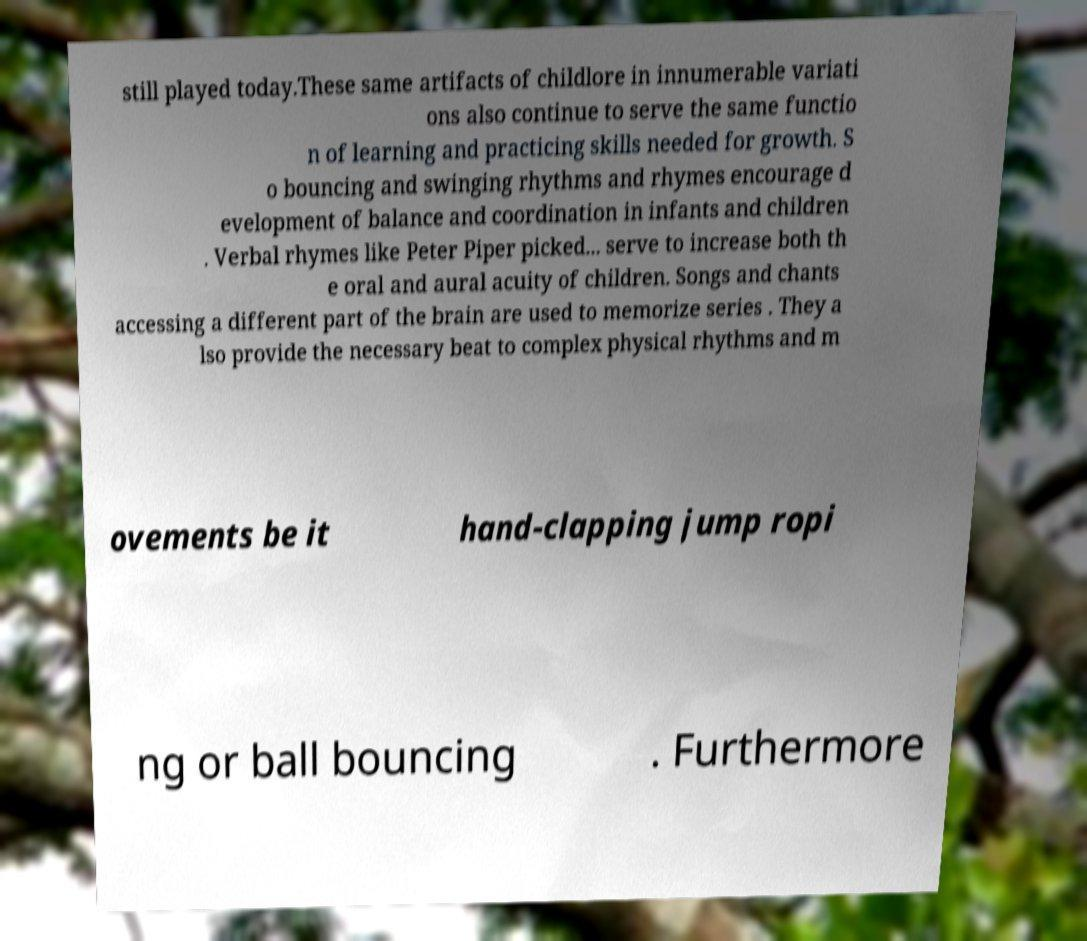I need the written content from this picture converted into text. Can you do that? still played today.These same artifacts of childlore in innumerable variati ons also continue to serve the same functio n of learning and practicing skills needed for growth. S o bouncing and swinging rhythms and rhymes encourage d evelopment of balance and coordination in infants and children . Verbal rhymes like Peter Piper picked... serve to increase both th e oral and aural acuity of children. Songs and chants accessing a different part of the brain are used to memorize series . They a lso provide the necessary beat to complex physical rhythms and m ovements be it hand-clapping jump ropi ng or ball bouncing . Furthermore 